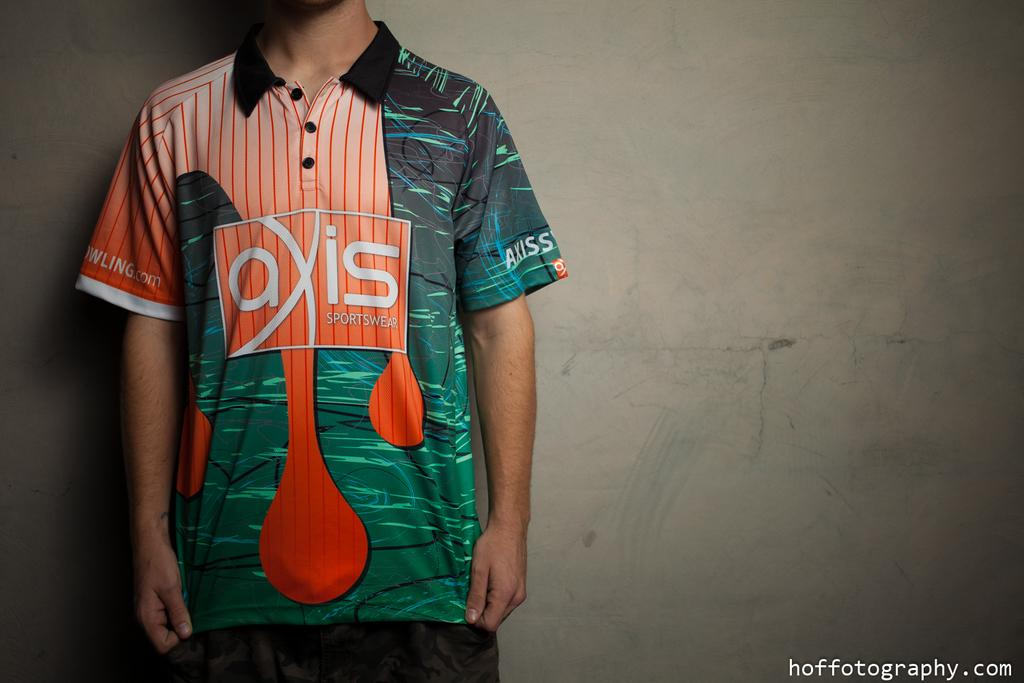<image>
Present a compact description of the photo's key features. a shirt that has the word axis on it 